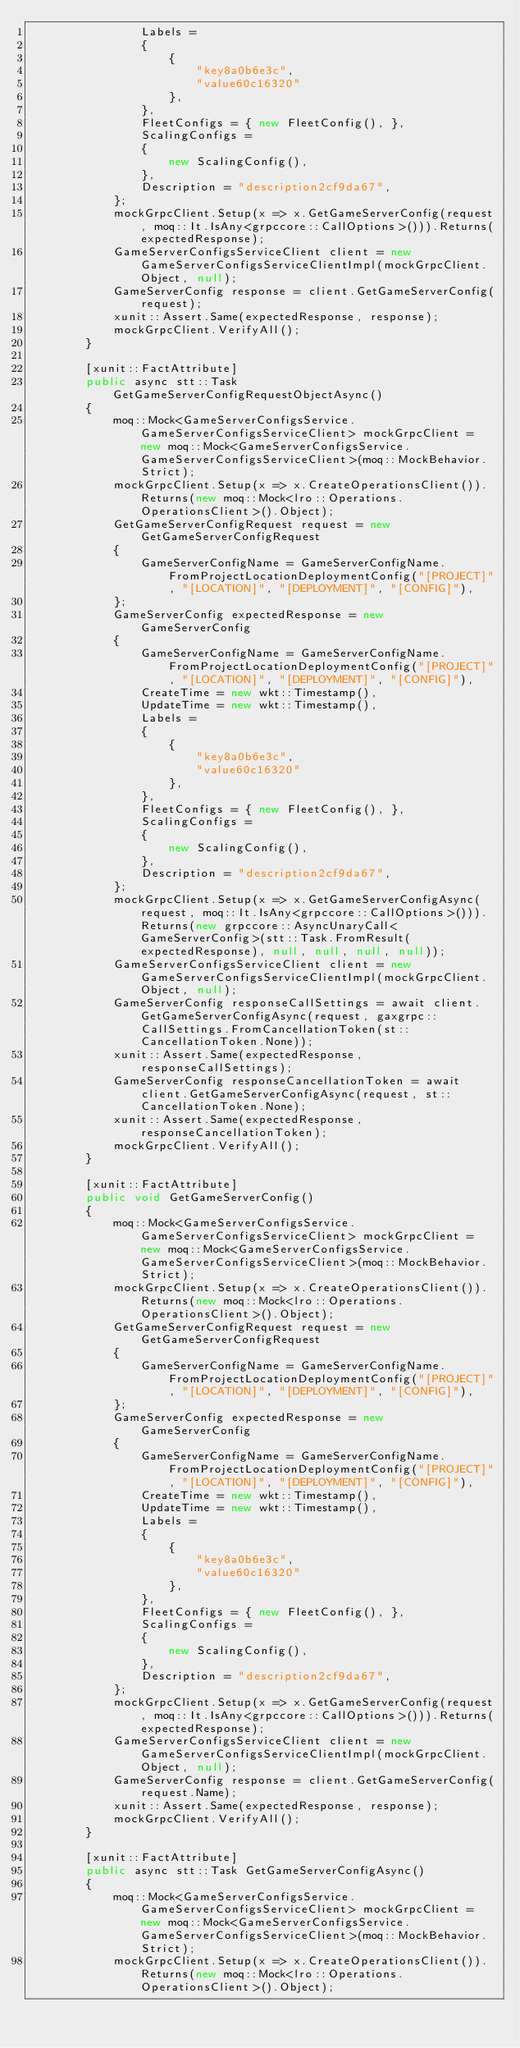<code> <loc_0><loc_0><loc_500><loc_500><_C#_>                Labels =
                {
                    {
                        "key8a0b6e3c",
                        "value60c16320"
                    },
                },
                FleetConfigs = { new FleetConfig(), },
                ScalingConfigs =
                {
                    new ScalingConfig(),
                },
                Description = "description2cf9da67",
            };
            mockGrpcClient.Setup(x => x.GetGameServerConfig(request, moq::It.IsAny<grpccore::CallOptions>())).Returns(expectedResponse);
            GameServerConfigsServiceClient client = new GameServerConfigsServiceClientImpl(mockGrpcClient.Object, null);
            GameServerConfig response = client.GetGameServerConfig(request);
            xunit::Assert.Same(expectedResponse, response);
            mockGrpcClient.VerifyAll();
        }

        [xunit::FactAttribute]
        public async stt::Task GetGameServerConfigRequestObjectAsync()
        {
            moq::Mock<GameServerConfigsService.GameServerConfigsServiceClient> mockGrpcClient = new moq::Mock<GameServerConfigsService.GameServerConfigsServiceClient>(moq::MockBehavior.Strict);
            mockGrpcClient.Setup(x => x.CreateOperationsClient()).Returns(new moq::Mock<lro::Operations.OperationsClient>().Object);
            GetGameServerConfigRequest request = new GetGameServerConfigRequest
            {
                GameServerConfigName = GameServerConfigName.FromProjectLocationDeploymentConfig("[PROJECT]", "[LOCATION]", "[DEPLOYMENT]", "[CONFIG]"),
            };
            GameServerConfig expectedResponse = new GameServerConfig
            {
                GameServerConfigName = GameServerConfigName.FromProjectLocationDeploymentConfig("[PROJECT]", "[LOCATION]", "[DEPLOYMENT]", "[CONFIG]"),
                CreateTime = new wkt::Timestamp(),
                UpdateTime = new wkt::Timestamp(),
                Labels =
                {
                    {
                        "key8a0b6e3c",
                        "value60c16320"
                    },
                },
                FleetConfigs = { new FleetConfig(), },
                ScalingConfigs =
                {
                    new ScalingConfig(),
                },
                Description = "description2cf9da67",
            };
            mockGrpcClient.Setup(x => x.GetGameServerConfigAsync(request, moq::It.IsAny<grpccore::CallOptions>())).Returns(new grpccore::AsyncUnaryCall<GameServerConfig>(stt::Task.FromResult(expectedResponse), null, null, null, null));
            GameServerConfigsServiceClient client = new GameServerConfigsServiceClientImpl(mockGrpcClient.Object, null);
            GameServerConfig responseCallSettings = await client.GetGameServerConfigAsync(request, gaxgrpc::CallSettings.FromCancellationToken(st::CancellationToken.None));
            xunit::Assert.Same(expectedResponse, responseCallSettings);
            GameServerConfig responseCancellationToken = await client.GetGameServerConfigAsync(request, st::CancellationToken.None);
            xunit::Assert.Same(expectedResponse, responseCancellationToken);
            mockGrpcClient.VerifyAll();
        }

        [xunit::FactAttribute]
        public void GetGameServerConfig()
        {
            moq::Mock<GameServerConfigsService.GameServerConfigsServiceClient> mockGrpcClient = new moq::Mock<GameServerConfigsService.GameServerConfigsServiceClient>(moq::MockBehavior.Strict);
            mockGrpcClient.Setup(x => x.CreateOperationsClient()).Returns(new moq::Mock<lro::Operations.OperationsClient>().Object);
            GetGameServerConfigRequest request = new GetGameServerConfigRequest
            {
                GameServerConfigName = GameServerConfigName.FromProjectLocationDeploymentConfig("[PROJECT]", "[LOCATION]", "[DEPLOYMENT]", "[CONFIG]"),
            };
            GameServerConfig expectedResponse = new GameServerConfig
            {
                GameServerConfigName = GameServerConfigName.FromProjectLocationDeploymentConfig("[PROJECT]", "[LOCATION]", "[DEPLOYMENT]", "[CONFIG]"),
                CreateTime = new wkt::Timestamp(),
                UpdateTime = new wkt::Timestamp(),
                Labels =
                {
                    {
                        "key8a0b6e3c",
                        "value60c16320"
                    },
                },
                FleetConfigs = { new FleetConfig(), },
                ScalingConfigs =
                {
                    new ScalingConfig(),
                },
                Description = "description2cf9da67",
            };
            mockGrpcClient.Setup(x => x.GetGameServerConfig(request, moq::It.IsAny<grpccore::CallOptions>())).Returns(expectedResponse);
            GameServerConfigsServiceClient client = new GameServerConfigsServiceClientImpl(mockGrpcClient.Object, null);
            GameServerConfig response = client.GetGameServerConfig(request.Name);
            xunit::Assert.Same(expectedResponse, response);
            mockGrpcClient.VerifyAll();
        }

        [xunit::FactAttribute]
        public async stt::Task GetGameServerConfigAsync()
        {
            moq::Mock<GameServerConfigsService.GameServerConfigsServiceClient> mockGrpcClient = new moq::Mock<GameServerConfigsService.GameServerConfigsServiceClient>(moq::MockBehavior.Strict);
            mockGrpcClient.Setup(x => x.CreateOperationsClient()).Returns(new moq::Mock<lro::Operations.OperationsClient>().Object);</code> 